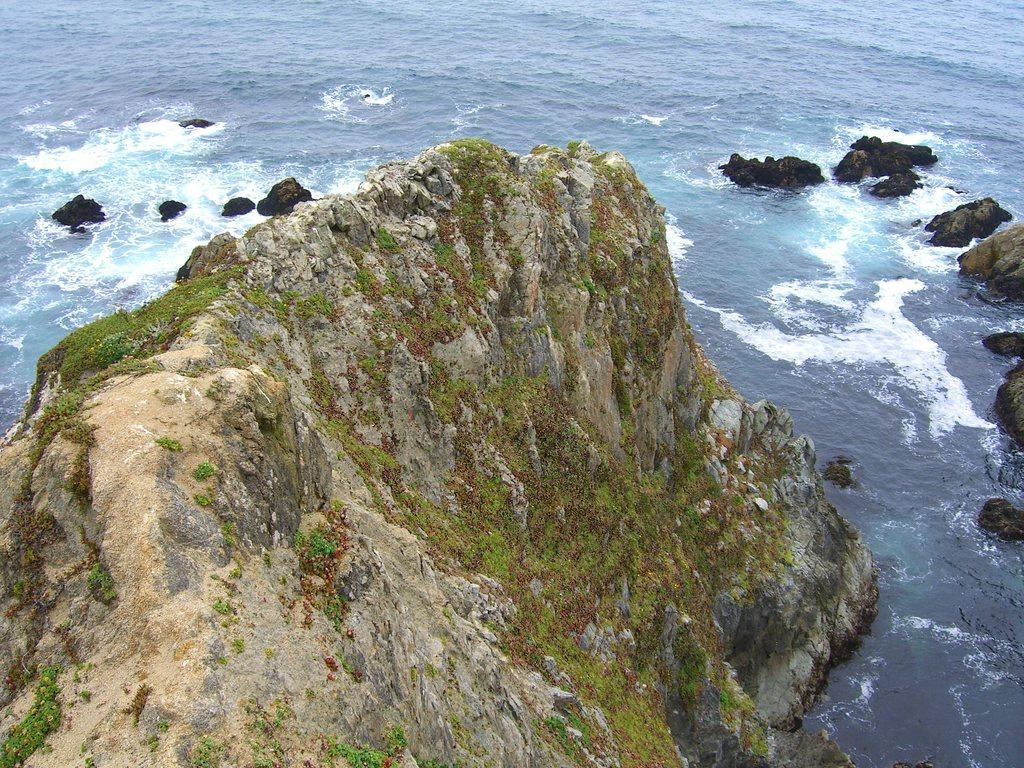Please provide a concise description of this image. In this image there are rocks. In the background there is water. 